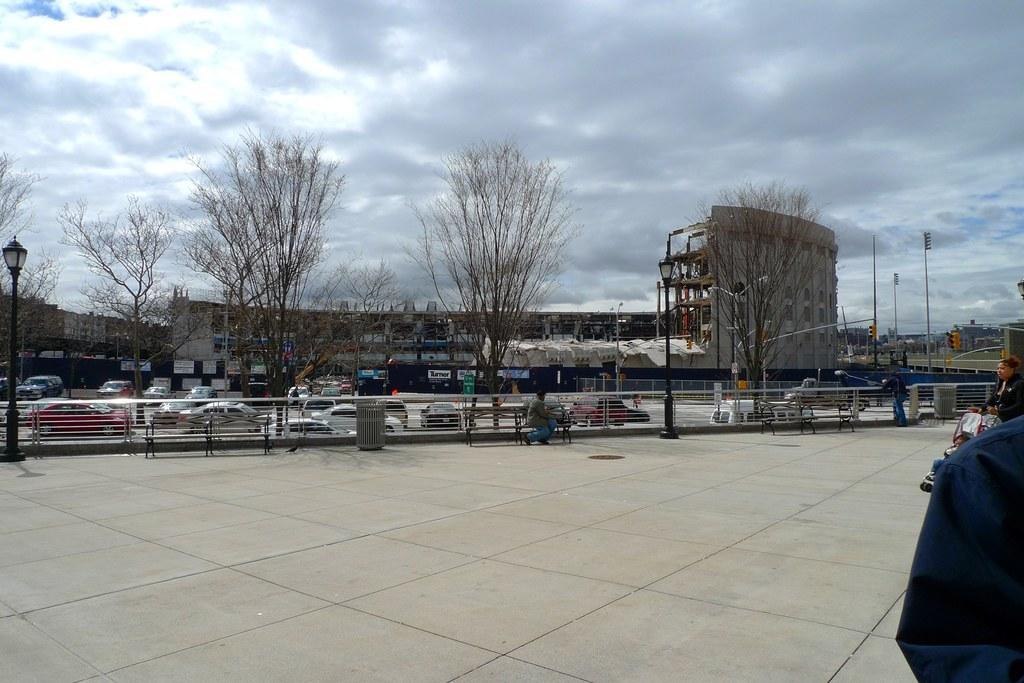How would you summarize this image in a sentence or two? In this image, there are a few people and vehicles. We can see the ground with some objects. There are a few trees. We can see some poles and benches. We can see the fence. There are a few buildings and boards with text. We can also see the sky with clouds. 